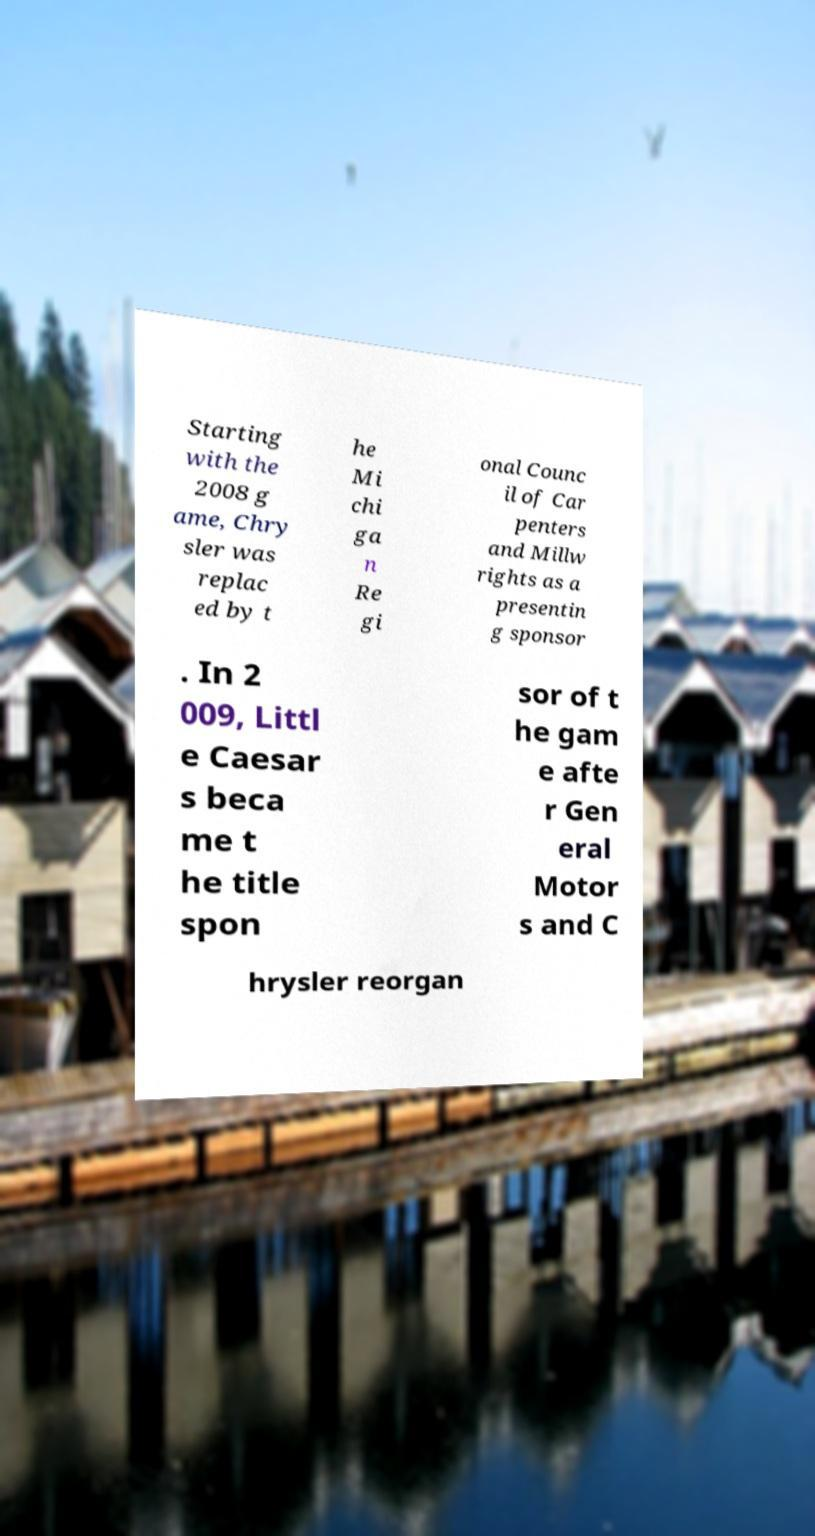Please identify and transcribe the text found in this image. Starting with the 2008 g ame, Chry sler was replac ed by t he Mi chi ga n Re gi onal Counc il of Car penters and Millw rights as a presentin g sponsor . In 2 009, Littl e Caesar s beca me t he title spon sor of t he gam e afte r Gen eral Motor s and C hrysler reorgan 